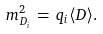<formula> <loc_0><loc_0><loc_500><loc_500>m _ { D _ { i } } ^ { 2 } \, = \, q _ { i } \langle D \rangle .</formula> 